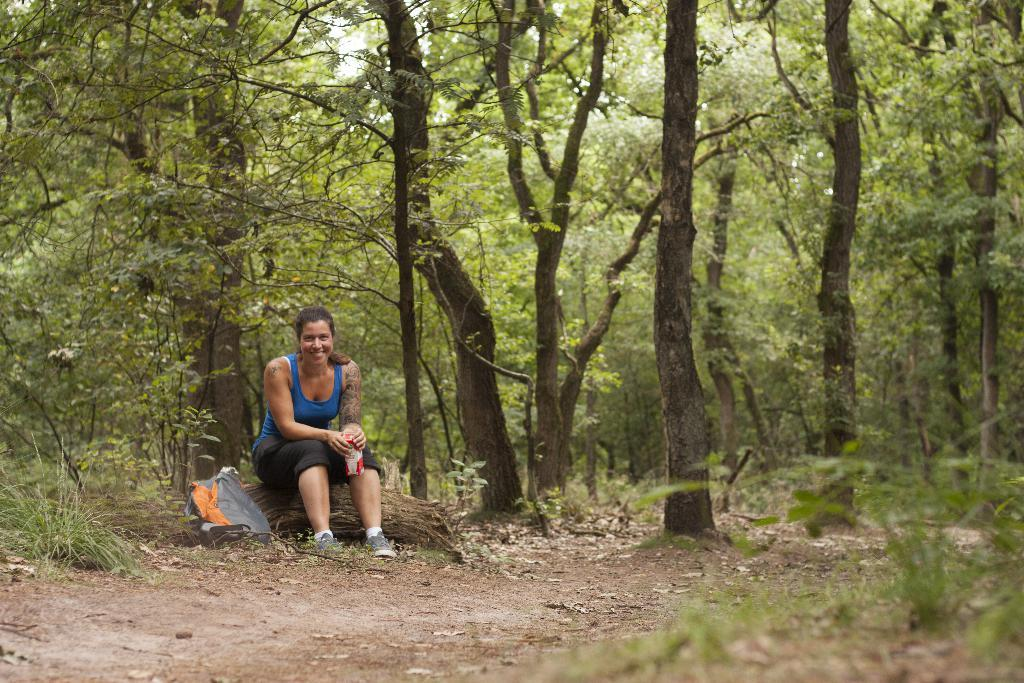Who is the main subject in the image? There is a woman in the image. What is the woman sitting on? The woman is seated on wood. What is the woman's emotional state in the image? The woman is laughing. What object is the woman holding in her hands? The woman is holding a bottle in her hands. What is located near the woman? There is a backpack near the woman. What can be seen in the background of the image? There are trees in the background of the image. What type of toy can be seen in the woman's hands in the image? There is no toy present in the image; the woman is holding a bottle in her hands. What event is the woman attending in the image? There is no indication of an event in the image; it simply shows a woman seated on wood, laughing, and holding a bottle. 